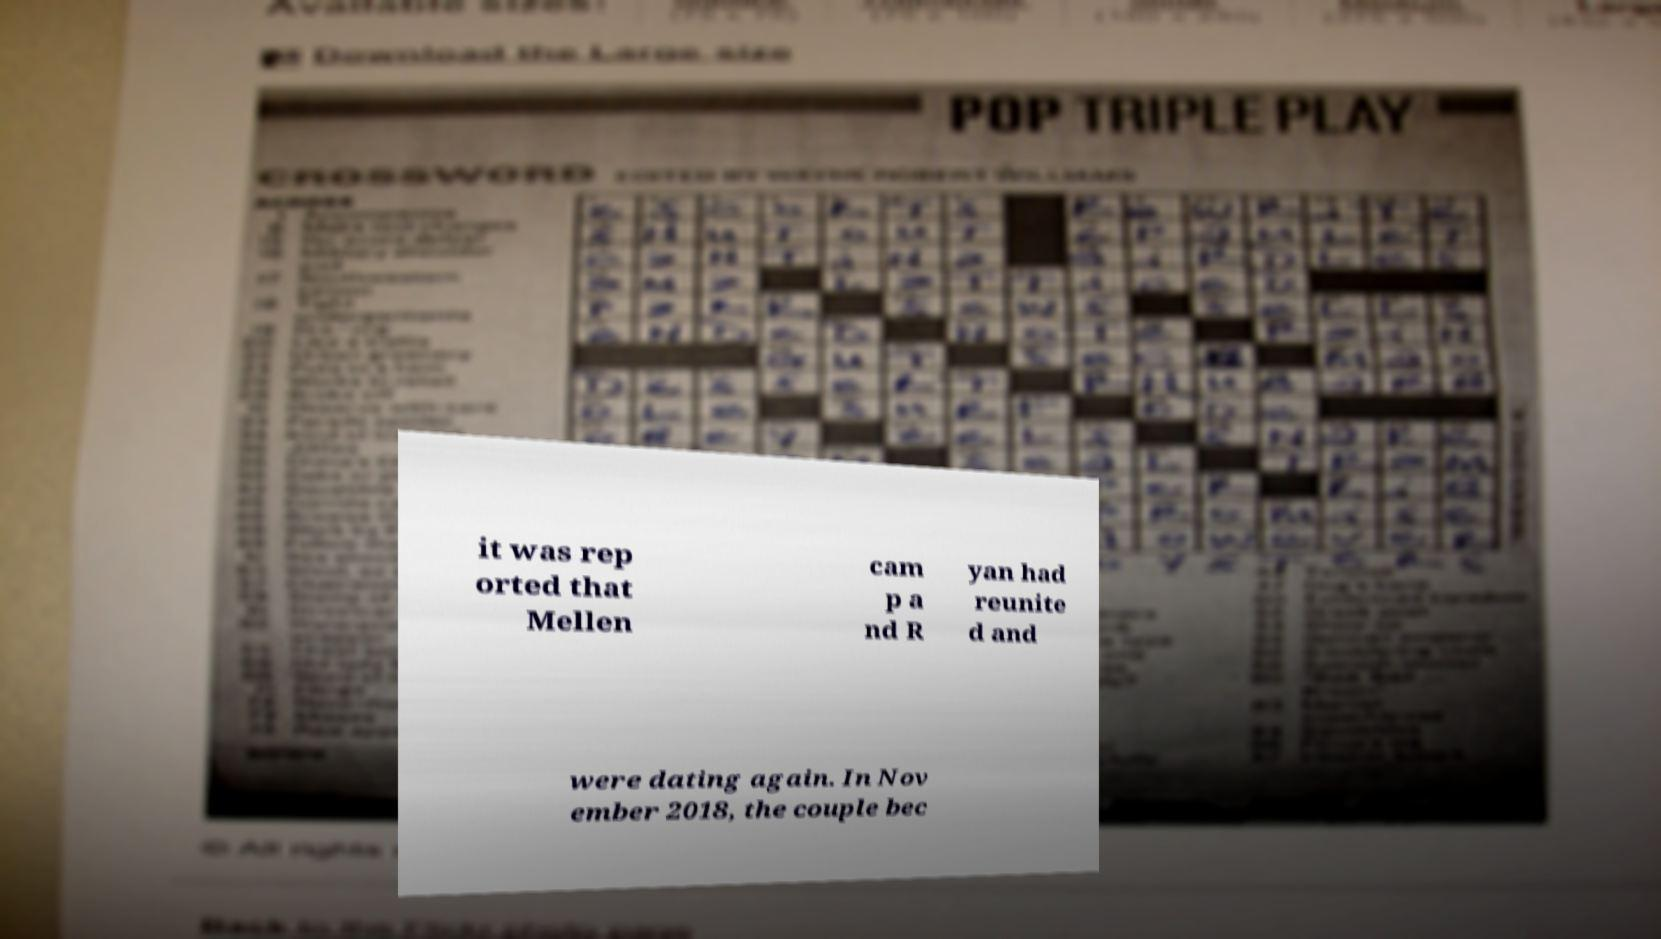Could you extract and type out the text from this image? it was rep orted that Mellen cam p a nd R yan had reunite d and were dating again. In Nov ember 2018, the couple bec 